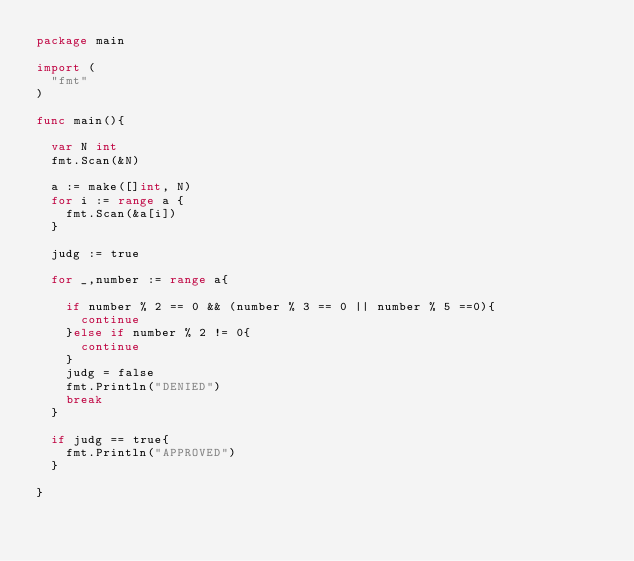<code> <loc_0><loc_0><loc_500><loc_500><_Go_>package main

import (
	"fmt"
)

func main(){

	var N int
	fmt.Scan(&N)
 
	a := make([]int, N)
	for i := range a {
		fmt.Scan(&a[i])
	}

	judg := true

	for _,number := range a{

		if number % 2 == 0 && (number % 3 == 0 || number % 5 ==0){
			continue
		}else if number % 2 != 0{
			continue
		}
		judg = false
		fmt.Println("DENIED")
		break
	}

	if judg == true{
		fmt.Println("APPROVED")
	}

}</code> 